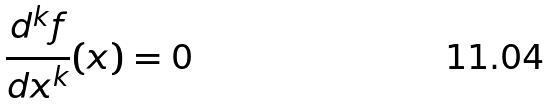<formula> <loc_0><loc_0><loc_500><loc_500>\frac { d ^ { k } f } { d x ^ { k } } ( x ) = 0</formula> 